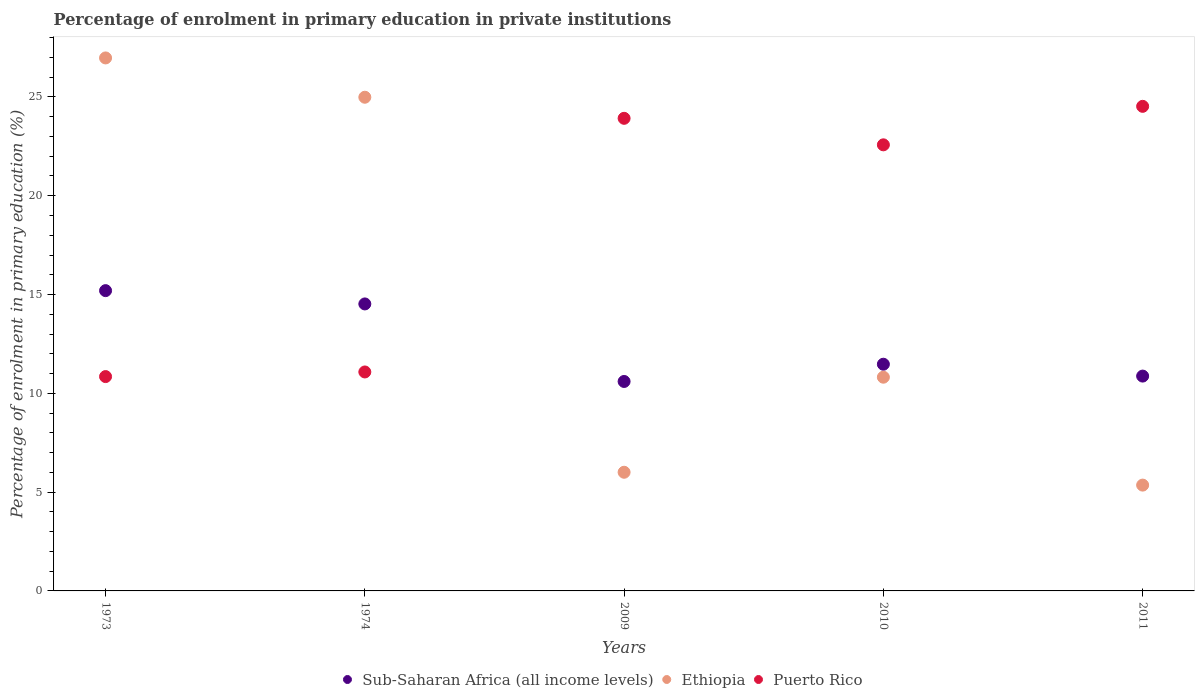What is the percentage of enrolment in primary education in Ethiopia in 1973?
Provide a short and direct response. 26.97. Across all years, what is the maximum percentage of enrolment in primary education in Ethiopia?
Ensure brevity in your answer.  26.97. Across all years, what is the minimum percentage of enrolment in primary education in Ethiopia?
Make the answer very short. 5.36. In which year was the percentage of enrolment in primary education in Sub-Saharan Africa (all income levels) minimum?
Your answer should be compact. 2009. What is the total percentage of enrolment in primary education in Sub-Saharan Africa (all income levels) in the graph?
Provide a succinct answer. 62.67. What is the difference between the percentage of enrolment in primary education in Puerto Rico in 2010 and that in 2011?
Provide a short and direct response. -1.95. What is the difference between the percentage of enrolment in primary education in Puerto Rico in 2011 and the percentage of enrolment in primary education in Ethiopia in 2009?
Your response must be concise. 18.52. What is the average percentage of enrolment in primary education in Puerto Rico per year?
Your response must be concise. 18.59. In the year 1973, what is the difference between the percentage of enrolment in primary education in Sub-Saharan Africa (all income levels) and percentage of enrolment in primary education in Puerto Rico?
Keep it short and to the point. 4.35. What is the ratio of the percentage of enrolment in primary education in Sub-Saharan Africa (all income levels) in 2010 to that in 2011?
Offer a very short reply. 1.06. What is the difference between the highest and the second highest percentage of enrolment in primary education in Puerto Rico?
Provide a short and direct response. 0.61. What is the difference between the highest and the lowest percentage of enrolment in primary education in Ethiopia?
Make the answer very short. 21.62. In how many years, is the percentage of enrolment in primary education in Puerto Rico greater than the average percentage of enrolment in primary education in Puerto Rico taken over all years?
Provide a succinct answer. 3. Is the percentage of enrolment in primary education in Puerto Rico strictly greater than the percentage of enrolment in primary education in Ethiopia over the years?
Provide a short and direct response. No. Is the percentage of enrolment in primary education in Ethiopia strictly less than the percentage of enrolment in primary education in Puerto Rico over the years?
Your answer should be compact. No. Does the graph contain grids?
Ensure brevity in your answer.  No. How many legend labels are there?
Your answer should be very brief. 3. What is the title of the graph?
Provide a succinct answer. Percentage of enrolment in primary education in private institutions. What is the label or title of the X-axis?
Provide a succinct answer. Years. What is the label or title of the Y-axis?
Ensure brevity in your answer.  Percentage of enrolment in primary education (%). What is the Percentage of enrolment in primary education (%) in Sub-Saharan Africa (all income levels) in 1973?
Provide a short and direct response. 15.2. What is the Percentage of enrolment in primary education (%) in Ethiopia in 1973?
Your answer should be very brief. 26.97. What is the Percentage of enrolment in primary education (%) of Puerto Rico in 1973?
Make the answer very short. 10.85. What is the Percentage of enrolment in primary education (%) in Sub-Saharan Africa (all income levels) in 1974?
Offer a terse response. 14.52. What is the Percentage of enrolment in primary education (%) in Ethiopia in 1974?
Your answer should be compact. 24.99. What is the Percentage of enrolment in primary education (%) of Puerto Rico in 1974?
Keep it short and to the point. 11.08. What is the Percentage of enrolment in primary education (%) in Sub-Saharan Africa (all income levels) in 2009?
Offer a terse response. 10.6. What is the Percentage of enrolment in primary education (%) in Ethiopia in 2009?
Give a very brief answer. 6.01. What is the Percentage of enrolment in primary education (%) of Puerto Rico in 2009?
Your answer should be very brief. 23.92. What is the Percentage of enrolment in primary education (%) in Sub-Saharan Africa (all income levels) in 2010?
Ensure brevity in your answer.  11.47. What is the Percentage of enrolment in primary education (%) of Ethiopia in 2010?
Your response must be concise. 10.82. What is the Percentage of enrolment in primary education (%) of Puerto Rico in 2010?
Your response must be concise. 22.58. What is the Percentage of enrolment in primary education (%) in Sub-Saharan Africa (all income levels) in 2011?
Provide a short and direct response. 10.87. What is the Percentage of enrolment in primary education (%) in Ethiopia in 2011?
Ensure brevity in your answer.  5.36. What is the Percentage of enrolment in primary education (%) of Puerto Rico in 2011?
Keep it short and to the point. 24.52. Across all years, what is the maximum Percentage of enrolment in primary education (%) in Sub-Saharan Africa (all income levels)?
Provide a succinct answer. 15.2. Across all years, what is the maximum Percentage of enrolment in primary education (%) in Ethiopia?
Ensure brevity in your answer.  26.97. Across all years, what is the maximum Percentage of enrolment in primary education (%) of Puerto Rico?
Give a very brief answer. 24.52. Across all years, what is the minimum Percentage of enrolment in primary education (%) in Sub-Saharan Africa (all income levels)?
Offer a very short reply. 10.6. Across all years, what is the minimum Percentage of enrolment in primary education (%) in Ethiopia?
Ensure brevity in your answer.  5.36. Across all years, what is the minimum Percentage of enrolment in primary education (%) of Puerto Rico?
Your answer should be very brief. 10.85. What is the total Percentage of enrolment in primary education (%) of Sub-Saharan Africa (all income levels) in the graph?
Offer a terse response. 62.67. What is the total Percentage of enrolment in primary education (%) in Ethiopia in the graph?
Make the answer very short. 74.14. What is the total Percentage of enrolment in primary education (%) in Puerto Rico in the graph?
Ensure brevity in your answer.  92.95. What is the difference between the Percentage of enrolment in primary education (%) of Sub-Saharan Africa (all income levels) in 1973 and that in 1974?
Your response must be concise. 0.67. What is the difference between the Percentage of enrolment in primary education (%) of Ethiopia in 1973 and that in 1974?
Your answer should be very brief. 1.99. What is the difference between the Percentage of enrolment in primary education (%) of Puerto Rico in 1973 and that in 1974?
Make the answer very short. -0.23. What is the difference between the Percentage of enrolment in primary education (%) in Sub-Saharan Africa (all income levels) in 1973 and that in 2009?
Ensure brevity in your answer.  4.6. What is the difference between the Percentage of enrolment in primary education (%) in Ethiopia in 1973 and that in 2009?
Keep it short and to the point. 20.97. What is the difference between the Percentage of enrolment in primary education (%) of Puerto Rico in 1973 and that in 2009?
Your answer should be compact. -13.07. What is the difference between the Percentage of enrolment in primary education (%) of Sub-Saharan Africa (all income levels) in 1973 and that in 2010?
Your answer should be compact. 3.72. What is the difference between the Percentage of enrolment in primary education (%) in Ethiopia in 1973 and that in 2010?
Your response must be concise. 16.16. What is the difference between the Percentage of enrolment in primary education (%) in Puerto Rico in 1973 and that in 2010?
Your answer should be very brief. -11.73. What is the difference between the Percentage of enrolment in primary education (%) in Sub-Saharan Africa (all income levels) in 1973 and that in 2011?
Give a very brief answer. 4.32. What is the difference between the Percentage of enrolment in primary education (%) in Ethiopia in 1973 and that in 2011?
Your answer should be very brief. 21.62. What is the difference between the Percentage of enrolment in primary education (%) in Puerto Rico in 1973 and that in 2011?
Make the answer very short. -13.68. What is the difference between the Percentage of enrolment in primary education (%) of Sub-Saharan Africa (all income levels) in 1974 and that in 2009?
Provide a short and direct response. 3.92. What is the difference between the Percentage of enrolment in primary education (%) in Ethiopia in 1974 and that in 2009?
Give a very brief answer. 18.98. What is the difference between the Percentage of enrolment in primary education (%) of Puerto Rico in 1974 and that in 2009?
Keep it short and to the point. -12.84. What is the difference between the Percentage of enrolment in primary education (%) in Sub-Saharan Africa (all income levels) in 1974 and that in 2010?
Offer a terse response. 3.05. What is the difference between the Percentage of enrolment in primary education (%) in Ethiopia in 1974 and that in 2010?
Provide a succinct answer. 14.17. What is the difference between the Percentage of enrolment in primary education (%) of Puerto Rico in 1974 and that in 2010?
Keep it short and to the point. -11.5. What is the difference between the Percentage of enrolment in primary education (%) of Sub-Saharan Africa (all income levels) in 1974 and that in 2011?
Give a very brief answer. 3.65. What is the difference between the Percentage of enrolment in primary education (%) of Ethiopia in 1974 and that in 2011?
Ensure brevity in your answer.  19.63. What is the difference between the Percentage of enrolment in primary education (%) in Puerto Rico in 1974 and that in 2011?
Provide a short and direct response. -13.44. What is the difference between the Percentage of enrolment in primary education (%) in Sub-Saharan Africa (all income levels) in 2009 and that in 2010?
Offer a very short reply. -0.87. What is the difference between the Percentage of enrolment in primary education (%) of Ethiopia in 2009 and that in 2010?
Provide a succinct answer. -4.81. What is the difference between the Percentage of enrolment in primary education (%) of Puerto Rico in 2009 and that in 2010?
Your answer should be compact. 1.34. What is the difference between the Percentage of enrolment in primary education (%) in Sub-Saharan Africa (all income levels) in 2009 and that in 2011?
Offer a very short reply. -0.27. What is the difference between the Percentage of enrolment in primary education (%) of Ethiopia in 2009 and that in 2011?
Offer a very short reply. 0.65. What is the difference between the Percentage of enrolment in primary education (%) of Puerto Rico in 2009 and that in 2011?
Your answer should be compact. -0.61. What is the difference between the Percentage of enrolment in primary education (%) in Sub-Saharan Africa (all income levels) in 2010 and that in 2011?
Ensure brevity in your answer.  0.6. What is the difference between the Percentage of enrolment in primary education (%) in Ethiopia in 2010 and that in 2011?
Offer a very short reply. 5.46. What is the difference between the Percentage of enrolment in primary education (%) in Puerto Rico in 2010 and that in 2011?
Provide a short and direct response. -1.95. What is the difference between the Percentage of enrolment in primary education (%) in Sub-Saharan Africa (all income levels) in 1973 and the Percentage of enrolment in primary education (%) in Ethiopia in 1974?
Offer a terse response. -9.79. What is the difference between the Percentage of enrolment in primary education (%) of Sub-Saharan Africa (all income levels) in 1973 and the Percentage of enrolment in primary education (%) of Puerto Rico in 1974?
Provide a succinct answer. 4.12. What is the difference between the Percentage of enrolment in primary education (%) of Ethiopia in 1973 and the Percentage of enrolment in primary education (%) of Puerto Rico in 1974?
Offer a terse response. 15.89. What is the difference between the Percentage of enrolment in primary education (%) of Sub-Saharan Africa (all income levels) in 1973 and the Percentage of enrolment in primary education (%) of Ethiopia in 2009?
Offer a very short reply. 9.19. What is the difference between the Percentage of enrolment in primary education (%) of Sub-Saharan Africa (all income levels) in 1973 and the Percentage of enrolment in primary education (%) of Puerto Rico in 2009?
Ensure brevity in your answer.  -8.72. What is the difference between the Percentage of enrolment in primary education (%) in Ethiopia in 1973 and the Percentage of enrolment in primary education (%) in Puerto Rico in 2009?
Your answer should be very brief. 3.06. What is the difference between the Percentage of enrolment in primary education (%) in Sub-Saharan Africa (all income levels) in 1973 and the Percentage of enrolment in primary education (%) in Ethiopia in 2010?
Your response must be concise. 4.38. What is the difference between the Percentage of enrolment in primary education (%) of Sub-Saharan Africa (all income levels) in 1973 and the Percentage of enrolment in primary education (%) of Puerto Rico in 2010?
Provide a short and direct response. -7.38. What is the difference between the Percentage of enrolment in primary education (%) in Ethiopia in 1973 and the Percentage of enrolment in primary education (%) in Puerto Rico in 2010?
Ensure brevity in your answer.  4.4. What is the difference between the Percentage of enrolment in primary education (%) of Sub-Saharan Africa (all income levels) in 1973 and the Percentage of enrolment in primary education (%) of Ethiopia in 2011?
Your answer should be very brief. 9.84. What is the difference between the Percentage of enrolment in primary education (%) in Sub-Saharan Africa (all income levels) in 1973 and the Percentage of enrolment in primary education (%) in Puerto Rico in 2011?
Keep it short and to the point. -9.33. What is the difference between the Percentage of enrolment in primary education (%) in Ethiopia in 1973 and the Percentage of enrolment in primary education (%) in Puerto Rico in 2011?
Keep it short and to the point. 2.45. What is the difference between the Percentage of enrolment in primary education (%) in Sub-Saharan Africa (all income levels) in 1974 and the Percentage of enrolment in primary education (%) in Ethiopia in 2009?
Provide a short and direct response. 8.52. What is the difference between the Percentage of enrolment in primary education (%) in Sub-Saharan Africa (all income levels) in 1974 and the Percentage of enrolment in primary education (%) in Puerto Rico in 2009?
Your answer should be compact. -9.39. What is the difference between the Percentage of enrolment in primary education (%) of Ethiopia in 1974 and the Percentage of enrolment in primary education (%) of Puerto Rico in 2009?
Keep it short and to the point. 1.07. What is the difference between the Percentage of enrolment in primary education (%) in Sub-Saharan Africa (all income levels) in 1974 and the Percentage of enrolment in primary education (%) in Ethiopia in 2010?
Provide a short and direct response. 3.71. What is the difference between the Percentage of enrolment in primary education (%) in Sub-Saharan Africa (all income levels) in 1974 and the Percentage of enrolment in primary education (%) in Puerto Rico in 2010?
Offer a terse response. -8.05. What is the difference between the Percentage of enrolment in primary education (%) in Ethiopia in 1974 and the Percentage of enrolment in primary education (%) in Puerto Rico in 2010?
Provide a succinct answer. 2.41. What is the difference between the Percentage of enrolment in primary education (%) of Sub-Saharan Africa (all income levels) in 1974 and the Percentage of enrolment in primary education (%) of Ethiopia in 2011?
Offer a terse response. 9.17. What is the difference between the Percentage of enrolment in primary education (%) of Sub-Saharan Africa (all income levels) in 1974 and the Percentage of enrolment in primary education (%) of Puerto Rico in 2011?
Offer a terse response. -10. What is the difference between the Percentage of enrolment in primary education (%) in Ethiopia in 1974 and the Percentage of enrolment in primary education (%) in Puerto Rico in 2011?
Keep it short and to the point. 0.46. What is the difference between the Percentage of enrolment in primary education (%) in Sub-Saharan Africa (all income levels) in 2009 and the Percentage of enrolment in primary education (%) in Ethiopia in 2010?
Your answer should be compact. -0.22. What is the difference between the Percentage of enrolment in primary education (%) of Sub-Saharan Africa (all income levels) in 2009 and the Percentage of enrolment in primary education (%) of Puerto Rico in 2010?
Your answer should be compact. -11.98. What is the difference between the Percentage of enrolment in primary education (%) in Ethiopia in 2009 and the Percentage of enrolment in primary education (%) in Puerto Rico in 2010?
Provide a short and direct response. -16.57. What is the difference between the Percentage of enrolment in primary education (%) of Sub-Saharan Africa (all income levels) in 2009 and the Percentage of enrolment in primary education (%) of Ethiopia in 2011?
Offer a very short reply. 5.25. What is the difference between the Percentage of enrolment in primary education (%) in Sub-Saharan Africa (all income levels) in 2009 and the Percentage of enrolment in primary education (%) in Puerto Rico in 2011?
Make the answer very short. -13.92. What is the difference between the Percentage of enrolment in primary education (%) in Ethiopia in 2009 and the Percentage of enrolment in primary education (%) in Puerto Rico in 2011?
Provide a succinct answer. -18.52. What is the difference between the Percentage of enrolment in primary education (%) in Sub-Saharan Africa (all income levels) in 2010 and the Percentage of enrolment in primary education (%) in Ethiopia in 2011?
Provide a short and direct response. 6.12. What is the difference between the Percentage of enrolment in primary education (%) of Sub-Saharan Africa (all income levels) in 2010 and the Percentage of enrolment in primary education (%) of Puerto Rico in 2011?
Ensure brevity in your answer.  -13.05. What is the difference between the Percentage of enrolment in primary education (%) of Ethiopia in 2010 and the Percentage of enrolment in primary education (%) of Puerto Rico in 2011?
Your response must be concise. -13.71. What is the average Percentage of enrolment in primary education (%) of Sub-Saharan Africa (all income levels) per year?
Your answer should be very brief. 12.53. What is the average Percentage of enrolment in primary education (%) of Ethiopia per year?
Keep it short and to the point. 14.83. What is the average Percentage of enrolment in primary education (%) of Puerto Rico per year?
Make the answer very short. 18.59. In the year 1973, what is the difference between the Percentage of enrolment in primary education (%) in Sub-Saharan Africa (all income levels) and Percentage of enrolment in primary education (%) in Ethiopia?
Make the answer very short. -11.78. In the year 1973, what is the difference between the Percentage of enrolment in primary education (%) in Sub-Saharan Africa (all income levels) and Percentage of enrolment in primary education (%) in Puerto Rico?
Offer a terse response. 4.35. In the year 1973, what is the difference between the Percentage of enrolment in primary education (%) of Ethiopia and Percentage of enrolment in primary education (%) of Puerto Rico?
Give a very brief answer. 16.13. In the year 1974, what is the difference between the Percentage of enrolment in primary education (%) of Sub-Saharan Africa (all income levels) and Percentage of enrolment in primary education (%) of Ethiopia?
Ensure brevity in your answer.  -10.46. In the year 1974, what is the difference between the Percentage of enrolment in primary education (%) of Sub-Saharan Africa (all income levels) and Percentage of enrolment in primary education (%) of Puerto Rico?
Ensure brevity in your answer.  3.44. In the year 1974, what is the difference between the Percentage of enrolment in primary education (%) of Ethiopia and Percentage of enrolment in primary education (%) of Puerto Rico?
Provide a succinct answer. 13.9. In the year 2009, what is the difference between the Percentage of enrolment in primary education (%) of Sub-Saharan Africa (all income levels) and Percentage of enrolment in primary education (%) of Ethiopia?
Your answer should be very brief. 4.59. In the year 2009, what is the difference between the Percentage of enrolment in primary education (%) of Sub-Saharan Africa (all income levels) and Percentage of enrolment in primary education (%) of Puerto Rico?
Give a very brief answer. -13.32. In the year 2009, what is the difference between the Percentage of enrolment in primary education (%) of Ethiopia and Percentage of enrolment in primary education (%) of Puerto Rico?
Your answer should be very brief. -17.91. In the year 2010, what is the difference between the Percentage of enrolment in primary education (%) in Sub-Saharan Africa (all income levels) and Percentage of enrolment in primary education (%) in Ethiopia?
Offer a very short reply. 0.66. In the year 2010, what is the difference between the Percentage of enrolment in primary education (%) of Sub-Saharan Africa (all income levels) and Percentage of enrolment in primary education (%) of Puerto Rico?
Ensure brevity in your answer.  -11.1. In the year 2010, what is the difference between the Percentage of enrolment in primary education (%) in Ethiopia and Percentage of enrolment in primary education (%) in Puerto Rico?
Provide a succinct answer. -11.76. In the year 2011, what is the difference between the Percentage of enrolment in primary education (%) in Sub-Saharan Africa (all income levels) and Percentage of enrolment in primary education (%) in Ethiopia?
Keep it short and to the point. 5.52. In the year 2011, what is the difference between the Percentage of enrolment in primary education (%) in Sub-Saharan Africa (all income levels) and Percentage of enrolment in primary education (%) in Puerto Rico?
Your answer should be compact. -13.65. In the year 2011, what is the difference between the Percentage of enrolment in primary education (%) of Ethiopia and Percentage of enrolment in primary education (%) of Puerto Rico?
Offer a very short reply. -19.17. What is the ratio of the Percentage of enrolment in primary education (%) in Sub-Saharan Africa (all income levels) in 1973 to that in 1974?
Ensure brevity in your answer.  1.05. What is the ratio of the Percentage of enrolment in primary education (%) in Ethiopia in 1973 to that in 1974?
Provide a succinct answer. 1.08. What is the ratio of the Percentage of enrolment in primary education (%) of Puerto Rico in 1973 to that in 1974?
Offer a very short reply. 0.98. What is the ratio of the Percentage of enrolment in primary education (%) in Sub-Saharan Africa (all income levels) in 1973 to that in 2009?
Keep it short and to the point. 1.43. What is the ratio of the Percentage of enrolment in primary education (%) of Ethiopia in 1973 to that in 2009?
Provide a succinct answer. 4.49. What is the ratio of the Percentage of enrolment in primary education (%) in Puerto Rico in 1973 to that in 2009?
Give a very brief answer. 0.45. What is the ratio of the Percentage of enrolment in primary education (%) in Sub-Saharan Africa (all income levels) in 1973 to that in 2010?
Give a very brief answer. 1.32. What is the ratio of the Percentage of enrolment in primary education (%) in Ethiopia in 1973 to that in 2010?
Provide a short and direct response. 2.49. What is the ratio of the Percentage of enrolment in primary education (%) of Puerto Rico in 1973 to that in 2010?
Your response must be concise. 0.48. What is the ratio of the Percentage of enrolment in primary education (%) of Sub-Saharan Africa (all income levels) in 1973 to that in 2011?
Ensure brevity in your answer.  1.4. What is the ratio of the Percentage of enrolment in primary education (%) in Ethiopia in 1973 to that in 2011?
Provide a short and direct response. 5.04. What is the ratio of the Percentage of enrolment in primary education (%) in Puerto Rico in 1973 to that in 2011?
Offer a very short reply. 0.44. What is the ratio of the Percentage of enrolment in primary education (%) of Sub-Saharan Africa (all income levels) in 1974 to that in 2009?
Give a very brief answer. 1.37. What is the ratio of the Percentage of enrolment in primary education (%) in Ethiopia in 1974 to that in 2009?
Provide a short and direct response. 4.16. What is the ratio of the Percentage of enrolment in primary education (%) of Puerto Rico in 1974 to that in 2009?
Offer a terse response. 0.46. What is the ratio of the Percentage of enrolment in primary education (%) of Sub-Saharan Africa (all income levels) in 1974 to that in 2010?
Keep it short and to the point. 1.27. What is the ratio of the Percentage of enrolment in primary education (%) of Ethiopia in 1974 to that in 2010?
Offer a very short reply. 2.31. What is the ratio of the Percentage of enrolment in primary education (%) in Puerto Rico in 1974 to that in 2010?
Give a very brief answer. 0.49. What is the ratio of the Percentage of enrolment in primary education (%) of Sub-Saharan Africa (all income levels) in 1974 to that in 2011?
Offer a terse response. 1.34. What is the ratio of the Percentage of enrolment in primary education (%) of Ethiopia in 1974 to that in 2011?
Provide a succinct answer. 4.67. What is the ratio of the Percentage of enrolment in primary education (%) of Puerto Rico in 1974 to that in 2011?
Ensure brevity in your answer.  0.45. What is the ratio of the Percentage of enrolment in primary education (%) in Sub-Saharan Africa (all income levels) in 2009 to that in 2010?
Provide a short and direct response. 0.92. What is the ratio of the Percentage of enrolment in primary education (%) of Ethiopia in 2009 to that in 2010?
Offer a terse response. 0.56. What is the ratio of the Percentage of enrolment in primary education (%) of Puerto Rico in 2009 to that in 2010?
Keep it short and to the point. 1.06. What is the ratio of the Percentage of enrolment in primary education (%) in Ethiopia in 2009 to that in 2011?
Provide a succinct answer. 1.12. What is the ratio of the Percentage of enrolment in primary education (%) in Puerto Rico in 2009 to that in 2011?
Make the answer very short. 0.98. What is the ratio of the Percentage of enrolment in primary education (%) of Sub-Saharan Africa (all income levels) in 2010 to that in 2011?
Your answer should be compact. 1.06. What is the ratio of the Percentage of enrolment in primary education (%) in Ethiopia in 2010 to that in 2011?
Provide a succinct answer. 2.02. What is the ratio of the Percentage of enrolment in primary education (%) in Puerto Rico in 2010 to that in 2011?
Offer a very short reply. 0.92. What is the difference between the highest and the second highest Percentage of enrolment in primary education (%) of Sub-Saharan Africa (all income levels)?
Provide a short and direct response. 0.67. What is the difference between the highest and the second highest Percentage of enrolment in primary education (%) of Ethiopia?
Make the answer very short. 1.99. What is the difference between the highest and the second highest Percentage of enrolment in primary education (%) of Puerto Rico?
Your answer should be compact. 0.61. What is the difference between the highest and the lowest Percentage of enrolment in primary education (%) in Sub-Saharan Africa (all income levels)?
Provide a succinct answer. 4.6. What is the difference between the highest and the lowest Percentage of enrolment in primary education (%) in Ethiopia?
Provide a short and direct response. 21.62. What is the difference between the highest and the lowest Percentage of enrolment in primary education (%) in Puerto Rico?
Ensure brevity in your answer.  13.68. 